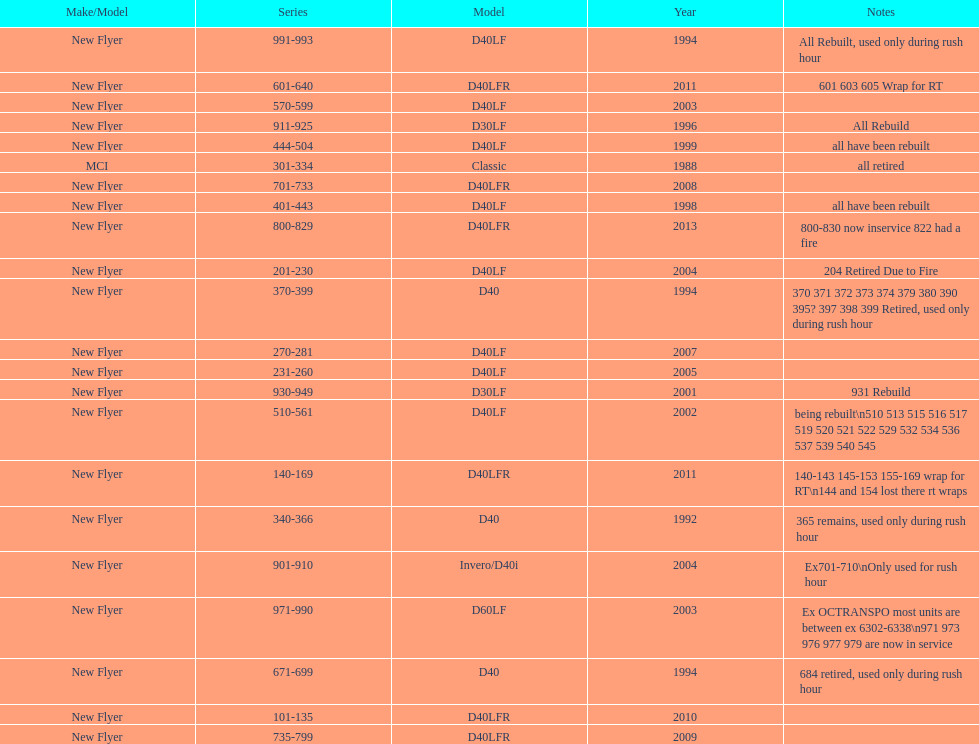Which buses are the newest in the current fleet? 800-829. Give me the full table as a dictionary. {'header': ['Make/Model', 'Series', 'Model', 'Year', 'Notes'], 'rows': [['New Flyer', '991-993', 'D40LF', '1994', 'All Rebuilt, used only during rush hour'], ['New Flyer', '601-640', 'D40LFR', '2011', '601 603 605 Wrap for RT'], ['New Flyer', '570-599', 'D40LF', '2003', ''], ['New Flyer', '911-925', 'D30LF', '1996', 'All Rebuild'], ['New Flyer', '444-504', 'D40LF', '1999', 'all have been rebuilt'], ['MCI', '301-334', 'Classic', '1988', 'all retired'], ['New Flyer', '701-733', 'D40LFR', '2008', ''], ['New Flyer', '401-443', 'D40LF', '1998', 'all have been rebuilt'], ['New Flyer', '800-829', 'D40LFR', '2013', '800-830 now inservice 822 had a fire'], ['New Flyer', '201-230', 'D40LF', '2004', '204 Retired Due to Fire'], ['New Flyer', '370-399', 'D40', '1994', '370 371 372 373 374 379 380 390 395? 397 398 399 Retired, used only during rush hour'], ['New Flyer', '270-281', 'D40LF', '2007', ''], ['New Flyer', '231-260', 'D40LF', '2005', ''], ['New Flyer', '930-949', 'D30LF', '2001', '931 Rebuild'], ['New Flyer', '510-561', 'D40LF', '2002', 'being rebuilt\\n510 513 515 516 517 519 520 521 522 529 532 534 536 537 539 540 545'], ['New Flyer', '140-169', 'D40LFR', '2011', '140-143 145-153 155-169 wrap for RT\\n144 and 154 lost there rt wraps'], ['New Flyer', '340-366', 'D40', '1992', '365 remains, used only during rush hour'], ['New Flyer', '901-910', 'Invero/D40i', '2004', 'Ex701-710\\nOnly used for rush hour'], ['New Flyer', '971-990', 'D60LF', '2003', 'Ex OCTRANSPO most units are between ex 6302-6338\\n971 973 976 977 979 are now in service'], ['New Flyer', '671-699', 'D40', '1994', '684 retired, used only during rush hour'], ['New Flyer', '101-135', 'D40LFR', '2010', ''], ['New Flyer', '735-799', 'D40LFR', '2009', '']]} 